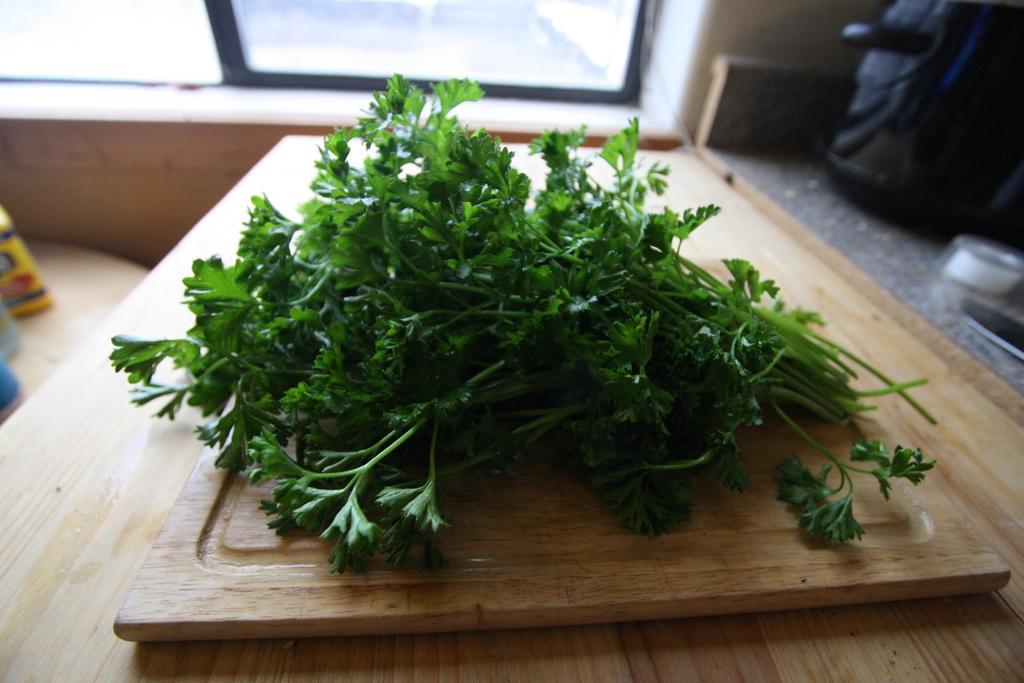How would you summarize this image in a sentence or two? In this image there are leafy vegetables on the chopping board, the chopping board is on top of a table, beside the table there is a kitchen platform, on top of the platform, there are some objects, in front of the table there is a glass window, beside the table there are some objects. 